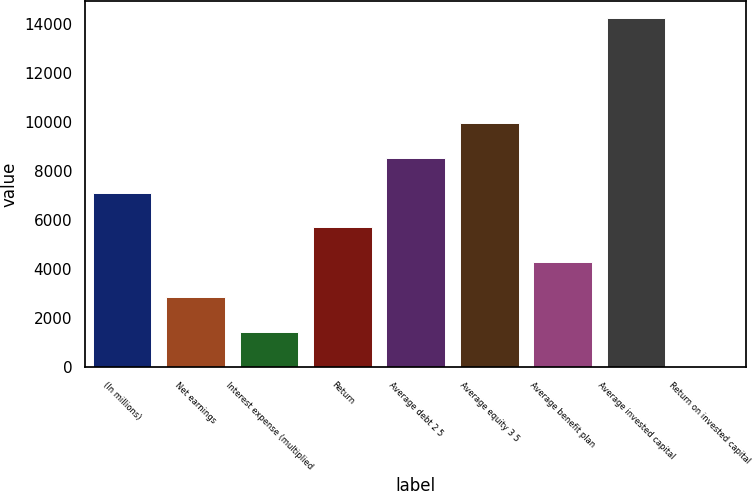Convert chart to OTSL. <chart><loc_0><loc_0><loc_500><loc_500><bar_chart><fcel>(In millions)<fcel>Net earnings<fcel>Interest expense (multiplied<fcel>Return<fcel>Average debt 2 5<fcel>Average equity 3 5<fcel>Average benefit plan<fcel>Average invested capital<fcel>Return on invested capital<nl><fcel>7126.9<fcel>2857.24<fcel>1434.02<fcel>5703.68<fcel>8550.12<fcel>9973.34<fcel>4280.46<fcel>14243<fcel>10.8<nl></chart> 